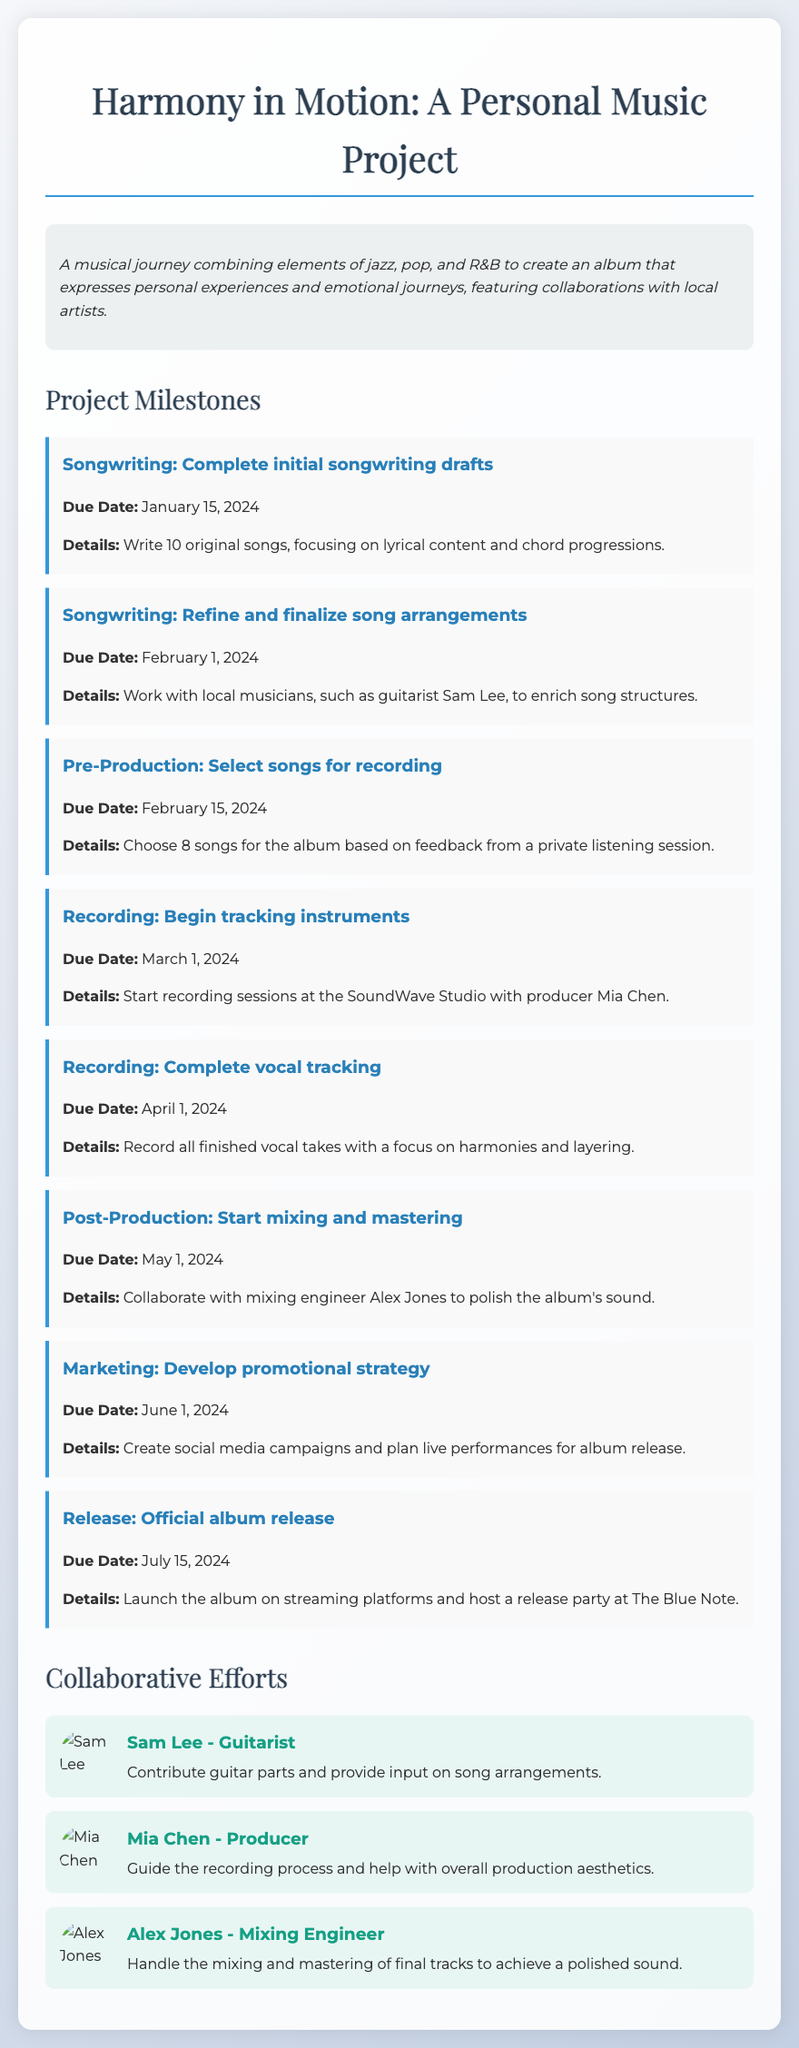What is the title of the project? The title is the heading of the memo, which reflects the essence of the music project.
Answer: Harmony in Motion: A Personal Music Project When is the deadline for finalizing song arrangements? The deadline for this milestone is specified under the songwriting section of the project milestones.
Answer: February 1, 2024 Who is the mixing engineer for the project? The name of the mixing engineer is listed among the collaborative efforts in the document.
Answer: Alex Jones How many original songs are planned for initial drafts? This number is provided in the details of the first milestone of the project.
Answer: 10 What is the date for the official album release? The release date is explicitly mentioned in the milestones section of the document.
Answer: July 15, 2024 Which studio will be used for recording sessions? This information is provided during the recording milestone section of the project.
Answer: SoundWave Studio Who will contribute guitar parts to the project? The collaborator's name is specified under the collaborative efforts section of the document.
Answer: Sam Lee What will be the focus during vocal tracking? The emphasis is indicated in the details of the milestone concerning vocal tracking.
Answer: Harmonies and layering 